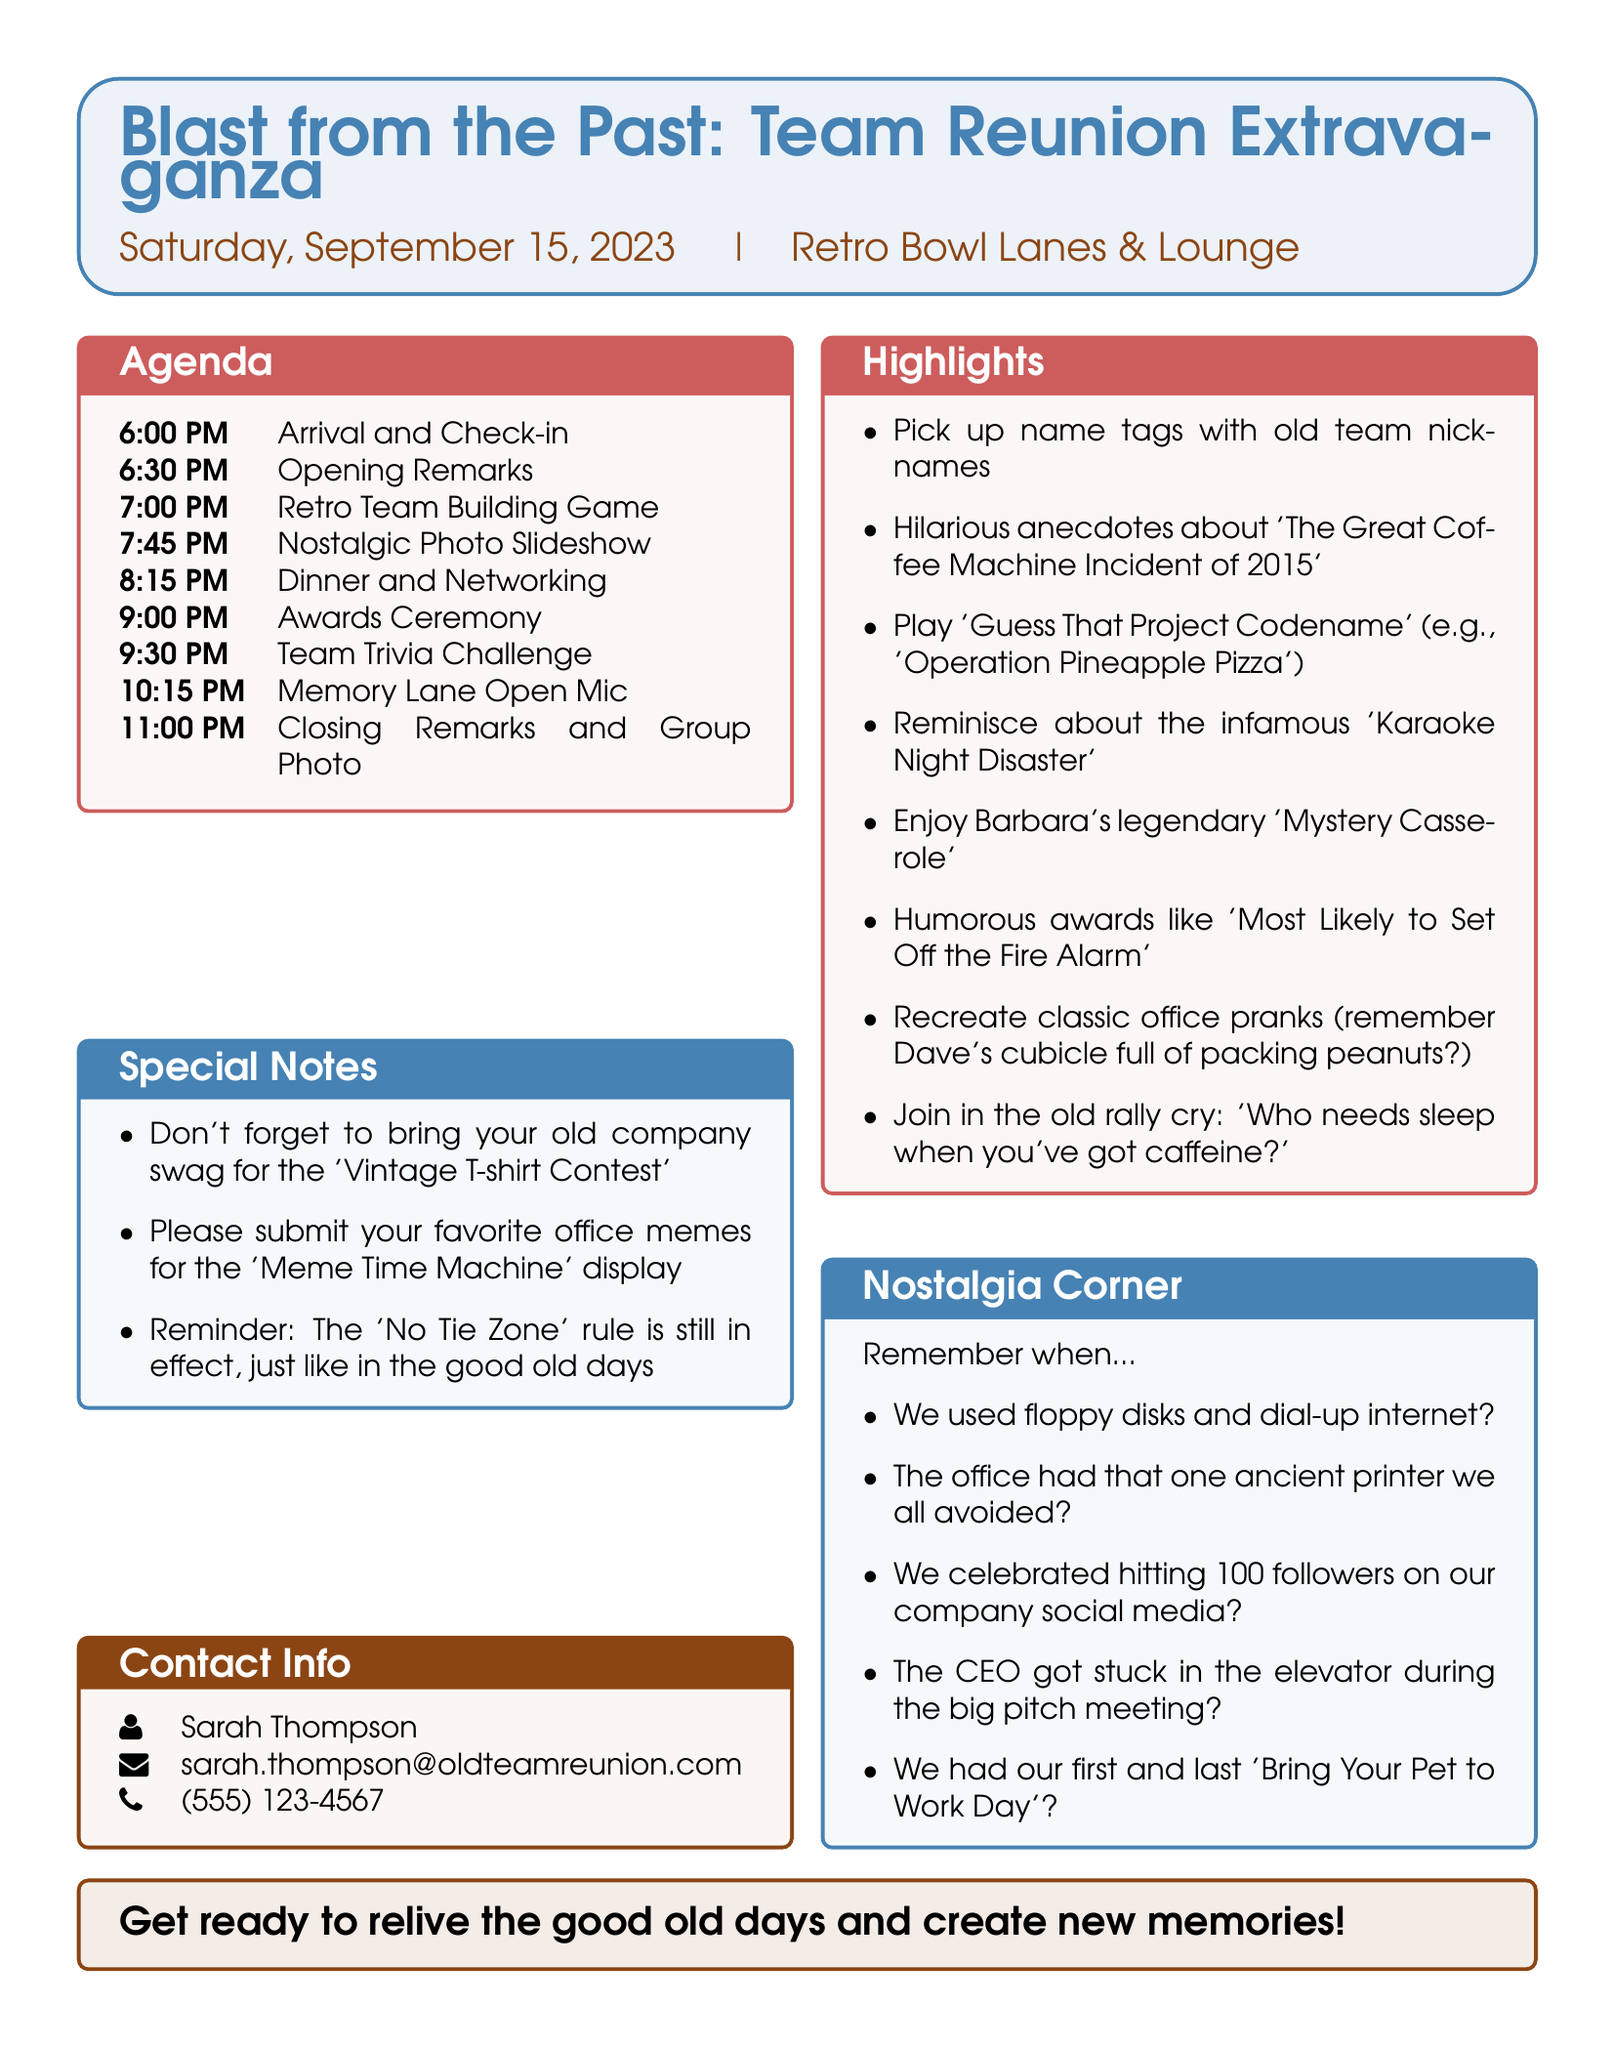what is the event title? The event title is specified at the top of the agenda.
Answer: Blast from the Past: Team Reunion Extravaganza what is the date of the event? The document lists the event date prominently.
Answer: Saturday, September 15, 2023 where is the venue located? The venue is mentioned right next to the date in the document.
Answer: Retro Bowl Lanes & Lounge what time does the dinner and networking start? The schedule provides a specific time for this activity.
Answer: 8:15 PM who will lead the closing remarks? The document indicates who is responsible for closing remarks.
Answer: Former manager name one food item featured in the dinner buffet. The agenda specifies a particular dish that attendees can enjoy.
Answer: Barbara's legendary "Mystery Casserole" what is the first activity of the evening? The agenda outlines the sequence of activities starting with arrival.
Answer: Arrival and Check-in what is one activity that involves sharing memories? The document mentions an activity focused on sharing past experiences.
Answer: Memory Lane Open Mic what humorous award category is included in the ceremony? The awards section lists a specific humorous award.
Answer: Most Likely to Set Off the Fire Alarm 